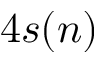Convert formula to latex. <formula><loc_0><loc_0><loc_500><loc_500>4 s ( n )</formula> 